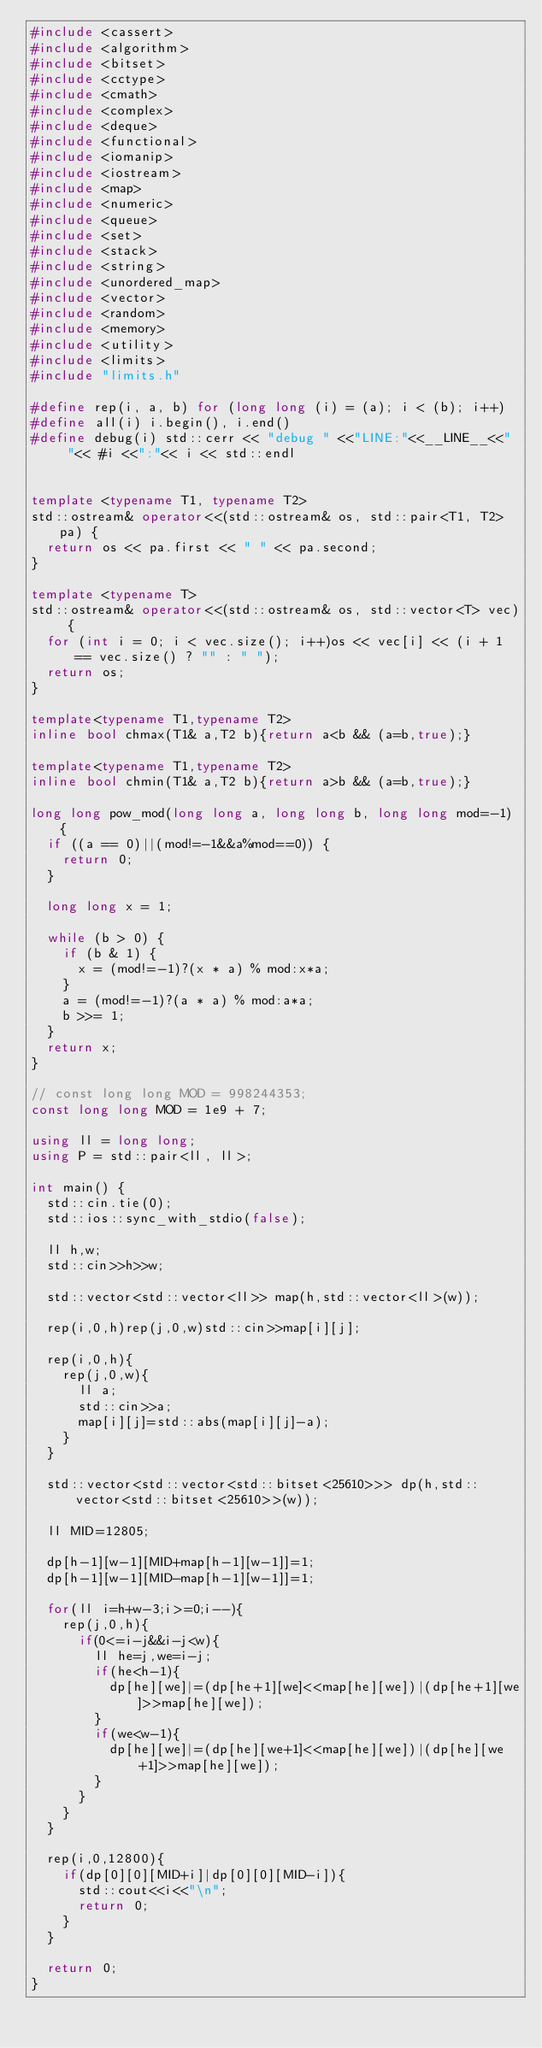Convert code to text. <code><loc_0><loc_0><loc_500><loc_500><_C++_>#include <cassert>
#include <algorithm>
#include <bitset>
#include <cctype>
#include <cmath>
#include <complex>
#include <deque>
#include <functional>
#include <iomanip>
#include <iostream>
#include <map>
#include <numeric>
#include <queue>
#include <set>
#include <stack>
#include <string>
#include <unordered_map>
#include <vector>
#include <random>
#include <memory>
#include <utility>
#include <limits>
#include "limits.h"
 
#define rep(i, a, b) for (long long (i) = (a); i < (b); i++)
#define all(i) i.begin(), i.end()
#define debug(i) std::cerr << "debug " <<"LINE:"<<__LINE__<<"  "<< #i <<":"<< i << std::endl

 
template <typename T1, typename T2>
std::ostream& operator<<(std::ostream& os, std::pair<T1, T2> pa) {
  return os << pa.first << " " << pa.second;
}
 
template <typename T>
std::ostream& operator<<(std::ostream& os, std::vector<T> vec) {
  for (int i = 0; i < vec.size(); i++)os << vec[i] << (i + 1 == vec.size() ? "" : " ");
  return os;
}
 
template<typename T1,typename T2>
inline bool chmax(T1& a,T2 b){return a<b && (a=b,true);}
 
template<typename T1,typename T2>
inline bool chmin(T1& a,T2 b){return a>b && (a=b,true);}
 
long long pow_mod(long long a, long long b, long long mod=-1) {
  if ((a == 0)||(mod!=-1&&a%mod==0)) {
    return 0;
  }
 
  long long x = 1;
 
  while (b > 0) {
    if (b & 1) {
      x = (mod!=-1)?(x * a) % mod:x*a;
    }
    a = (mod!=-1)?(a * a) % mod:a*a;
    b >>= 1;
  }
  return x;
}
 
// const long long MOD = 998244353;
const long long MOD = 1e9 + 7;

using ll = long long;
using P = std::pair<ll, ll>;

int main() {
  std::cin.tie(0);
  std::ios::sync_with_stdio(false);

  ll h,w;
  std::cin>>h>>w;

  std::vector<std::vector<ll>> map(h,std::vector<ll>(w));

  rep(i,0,h)rep(j,0,w)std::cin>>map[i][j];

  rep(i,0,h){
    rep(j,0,w){
      ll a;
      std::cin>>a;
      map[i][j]=std::abs(map[i][j]-a);
    }
  }

  std::vector<std::vector<std::bitset<25610>>> dp(h,std::vector<std::bitset<25610>>(w));

  ll MID=12805;

  dp[h-1][w-1][MID+map[h-1][w-1]]=1;
  dp[h-1][w-1][MID-map[h-1][w-1]]=1;

  for(ll i=h+w-3;i>=0;i--){
    rep(j,0,h){
      if(0<=i-j&&i-j<w){
        ll he=j,we=i-j;
        if(he<h-1){
          dp[he][we]|=(dp[he+1][we]<<map[he][we])|(dp[he+1][we]>>map[he][we]);
        }
        if(we<w-1){
          dp[he][we]|=(dp[he][we+1]<<map[he][we])|(dp[he][we+1]>>map[he][we]);
        }
      }
    }
  }

  rep(i,0,12800){
    if(dp[0][0][MID+i]|dp[0][0][MID-i]){
      std::cout<<i<<"\n";
      return 0;
    }
  }

  return 0;
}
</code> 